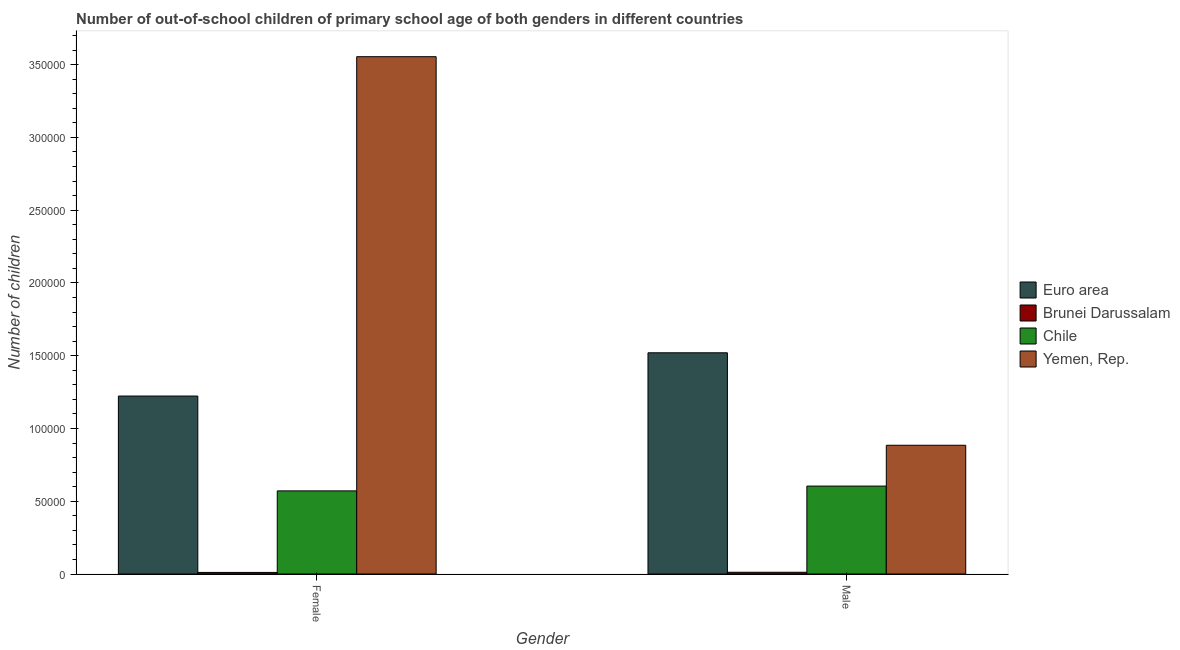How many different coloured bars are there?
Ensure brevity in your answer.  4. How many groups of bars are there?
Your answer should be compact. 2. Are the number of bars per tick equal to the number of legend labels?
Give a very brief answer. Yes. How many bars are there on the 2nd tick from the left?
Keep it short and to the point. 4. How many bars are there on the 1st tick from the right?
Your answer should be very brief. 4. What is the label of the 1st group of bars from the left?
Give a very brief answer. Female. What is the number of female out-of-school students in Brunei Darussalam?
Give a very brief answer. 1079. Across all countries, what is the maximum number of female out-of-school students?
Offer a very short reply. 3.55e+05. Across all countries, what is the minimum number of male out-of-school students?
Ensure brevity in your answer.  1196. In which country was the number of female out-of-school students maximum?
Provide a short and direct response. Yemen, Rep. In which country was the number of male out-of-school students minimum?
Provide a short and direct response. Brunei Darussalam. What is the total number of male out-of-school students in the graph?
Keep it short and to the point. 3.02e+05. What is the difference between the number of female out-of-school students in Euro area and that in Yemen, Rep.?
Offer a very short reply. -2.33e+05. What is the difference between the number of male out-of-school students in Euro area and the number of female out-of-school students in Brunei Darussalam?
Your response must be concise. 1.51e+05. What is the average number of female out-of-school students per country?
Offer a very short reply. 1.34e+05. What is the difference between the number of female out-of-school students and number of male out-of-school students in Chile?
Provide a short and direct response. -3297. In how many countries, is the number of male out-of-school students greater than 330000 ?
Offer a very short reply. 0. What is the ratio of the number of male out-of-school students in Yemen, Rep. to that in Euro area?
Offer a very short reply. 0.58. Is the number of male out-of-school students in Brunei Darussalam less than that in Chile?
Offer a terse response. Yes. In how many countries, is the number of male out-of-school students greater than the average number of male out-of-school students taken over all countries?
Provide a short and direct response. 2. What does the 1st bar from the left in Male represents?
Keep it short and to the point. Euro area. What does the 4th bar from the right in Female represents?
Provide a short and direct response. Euro area. Are all the bars in the graph horizontal?
Offer a terse response. No. How many countries are there in the graph?
Provide a short and direct response. 4. Are the values on the major ticks of Y-axis written in scientific E-notation?
Your answer should be compact. No. Does the graph contain any zero values?
Give a very brief answer. No. Does the graph contain grids?
Give a very brief answer. No. How many legend labels are there?
Your response must be concise. 4. How are the legend labels stacked?
Provide a succinct answer. Vertical. What is the title of the graph?
Your answer should be very brief. Number of out-of-school children of primary school age of both genders in different countries. What is the label or title of the X-axis?
Your response must be concise. Gender. What is the label or title of the Y-axis?
Your answer should be compact. Number of children. What is the Number of children in Euro area in Female?
Your response must be concise. 1.22e+05. What is the Number of children of Brunei Darussalam in Female?
Provide a succinct answer. 1079. What is the Number of children in Chile in Female?
Provide a succinct answer. 5.71e+04. What is the Number of children of Yemen, Rep. in Female?
Ensure brevity in your answer.  3.55e+05. What is the Number of children of Euro area in Male?
Your answer should be very brief. 1.52e+05. What is the Number of children of Brunei Darussalam in Male?
Ensure brevity in your answer.  1196. What is the Number of children in Chile in Male?
Your answer should be very brief. 6.04e+04. What is the Number of children in Yemen, Rep. in Male?
Provide a succinct answer. 8.85e+04. Across all Gender, what is the maximum Number of children of Euro area?
Make the answer very short. 1.52e+05. Across all Gender, what is the maximum Number of children in Brunei Darussalam?
Your answer should be compact. 1196. Across all Gender, what is the maximum Number of children of Chile?
Offer a very short reply. 6.04e+04. Across all Gender, what is the maximum Number of children of Yemen, Rep.?
Your answer should be very brief. 3.55e+05. Across all Gender, what is the minimum Number of children of Euro area?
Provide a short and direct response. 1.22e+05. Across all Gender, what is the minimum Number of children of Brunei Darussalam?
Your answer should be very brief. 1079. Across all Gender, what is the minimum Number of children of Chile?
Provide a short and direct response. 5.71e+04. Across all Gender, what is the minimum Number of children in Yemen, Rep.?
Your answer should be very brief. 8.85e+04. What is the total Number of children in Euro area in the graph?
Your answer should be compact. 2.74e+05. What is the total Number of children in Brunei Darussalam in the graph?
Ensure brevity in your answer.  2275. What is the total Number of children of Chile in the graph?
Keep it short and to the point. 1.18e+05. What is the total Number of children of Yemen, Rep. in the graph?
Your answer should be very brief. 4.44e+05. What is the difference between the Number of children of Euro area in Female and that in Male?
Make the answer very short. -2.97e+04. What is the difference between the Number of children in Brunei Darussalam in Female and that in Male?
Provide a succinct answer. -117. What is the difference between the Number of children in Chile in Female and that in Male?
Your answer should be very brief. -3297. What is the difference between the Number of children in Yemen, Rep. in Female and that in Male?
Provide a succinct answer. 2.67e+05. What is the difference between the Number of children in Euro area in Female and the Number of children in Brunei Darussalam in Male?
Provide a succinct answer. 1.21e+05. What is the difference between the Number of children of Euro area in Female and the Number of children of Chile in Male?
Make the answer very short. 6.19e+04. What is the difference between the Number of children of Euro area in Female and the Number of children of Yemen, Rep. in Male?
Offer a terse response. 3.38e+04. What is the difference between the Number of children in Brunei Darussalam in Female and the Number of children in Chile in Male?
Your response must be concise. -5.93e+04. What is the difference between the Number of children of Brunei Darussalam in Female and the Number of children of Yemen, Rep. in Male?
Keep it short and to the point. -8.74e+04. What is the difference between the Number of children of Chile in Female and the Number of children of Yemen, Rep. in Male?
Your answer should be very brief. -3.14e+04. What is the average Number of children in Euro area per Gender?
Keep it short and to the point. 1.37e+05. What is the average Number of children in Brunei Darussalam per Gender?
Your answer should be very brief. 1137.5. What is the average Number of children of Chile per Gender?
Your answer should be very brief. 5.88e+04. What is the average Number of children of Yemen, Rep. per Gender?
Your answer should be compact. 2.22e+05. What is the difference between the Number of children of Euro area and Number of children of Brunei Darussalam in Female?
Give a very brief answer. 1.21e+05. What is the difference between the Number of children in Euro area and Number of children in Chile in Female?
Your answer should be compact. 6.52e+04. What is the difference between the Number of children in Euro area and Number of children in Yemen, Rep. in Female?
Keep it short and to the point. -2.33e+05. What is the difference between the Number of children in Brunei Darussalam and Number of children in Chile in Female?
Your answer should be compact. -5.60e+04. What is the difference between the Number of children in Brunei Darussalam and Number of children in Yemen, Rep. in Female?
Your response must be concise. -3.54e+05. What is the difference between the Number of children of Chile and Number of children of Yemen, Rep. in Female?
Provide a short and direct response. -2.98e+05. What is the difference between the Number of children in Euro area and Number of children in Brunei Darussalam in Male?
Provide a succinct answer. 1.51e+05. What is the difference between the Number of children in Euro area and Number of children in Chile in Male?
Your response must be concise. 9.16e+04. What is the difference between the Number of children of Euro area and Number of children of Yemen, Rep. in Male?
Ensure brevity in your answer.  6.35e+04. What is the difference between the Number of children of Brunei Darussalam and Number of children of Chile in Male?
Offer a terse response. -5.92e+04. What is the difference between the Number of children of Brunei Darussalam and Number of children of Yemen, Rep. in Male?
Offer a very short reply. -8.73e+04. What is the difference between the Number of children in Chile and Number of children in Yemen, Rep. in Male?
Offer a terse response. -2.81e+04. What is the ratio of the Number of children in Euro area in Female to that in Male?
Offer a very short reply. 0.8. What is the ratio of the Number of children in Brunei Darussalam in Female to that in Male?
Provide a short and direct response. 0.9. What is the ratio of the Number of children in Chile in Female to that in Male?
Offer a terse response. 0.95. What is the ratio of the Number of children in Yemen, Rep. in Female to that in Male?
Give a very brief answer. 4.02. What is the difference between the highest and the second highest Number of children of Euro area?
Offer a very short reply. 2.97e+04. What is the difference between the highest and the second highest Number of children of Brunei Darussalam?
Keep it short and to the point. 117. What is the difference between the highest and the second highest Number of children of Chile?
Offer a terse response. 3297. What is the difference between the highest and the second highest Number of children in Yemen, Rep.?
Your response must be concise. 2.67e+05. What is the difference between the highest and the lowest Number of children in Euro area?
Your answer should be compact. 2.97e+04. What is the difference between the highest and the lowest Number of children of Brunei Darussalam?
Keep it short and to the point. 117. What is the difference between the highest and the lowest Number of children in Chile?
Ensure brevity in your answer.  3297. What is the difference between the highest and the lowest Number of children in Yemen, Rep.?
Keep it short and to the point. 2.67e+05. 